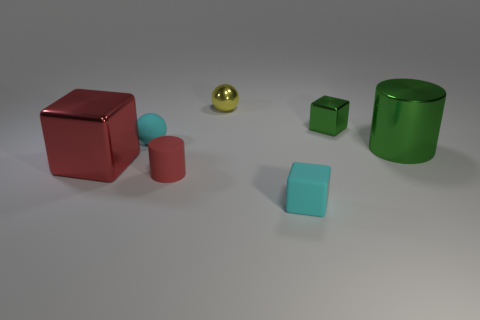Add 1 tiny rubber things. How many objects exist? 8 Subtract all cylinders. How many objects are left? 5 Subtract all green blocks. Subtract all cyan cubes. How many objects are left? 5 Add 4 cyan balls. How many cyan balls are left? 5 Add 4 blue rubber objects. How many blue rubber objects exist? 4 Subtract 1 red blocks. How many objects are left? 6 